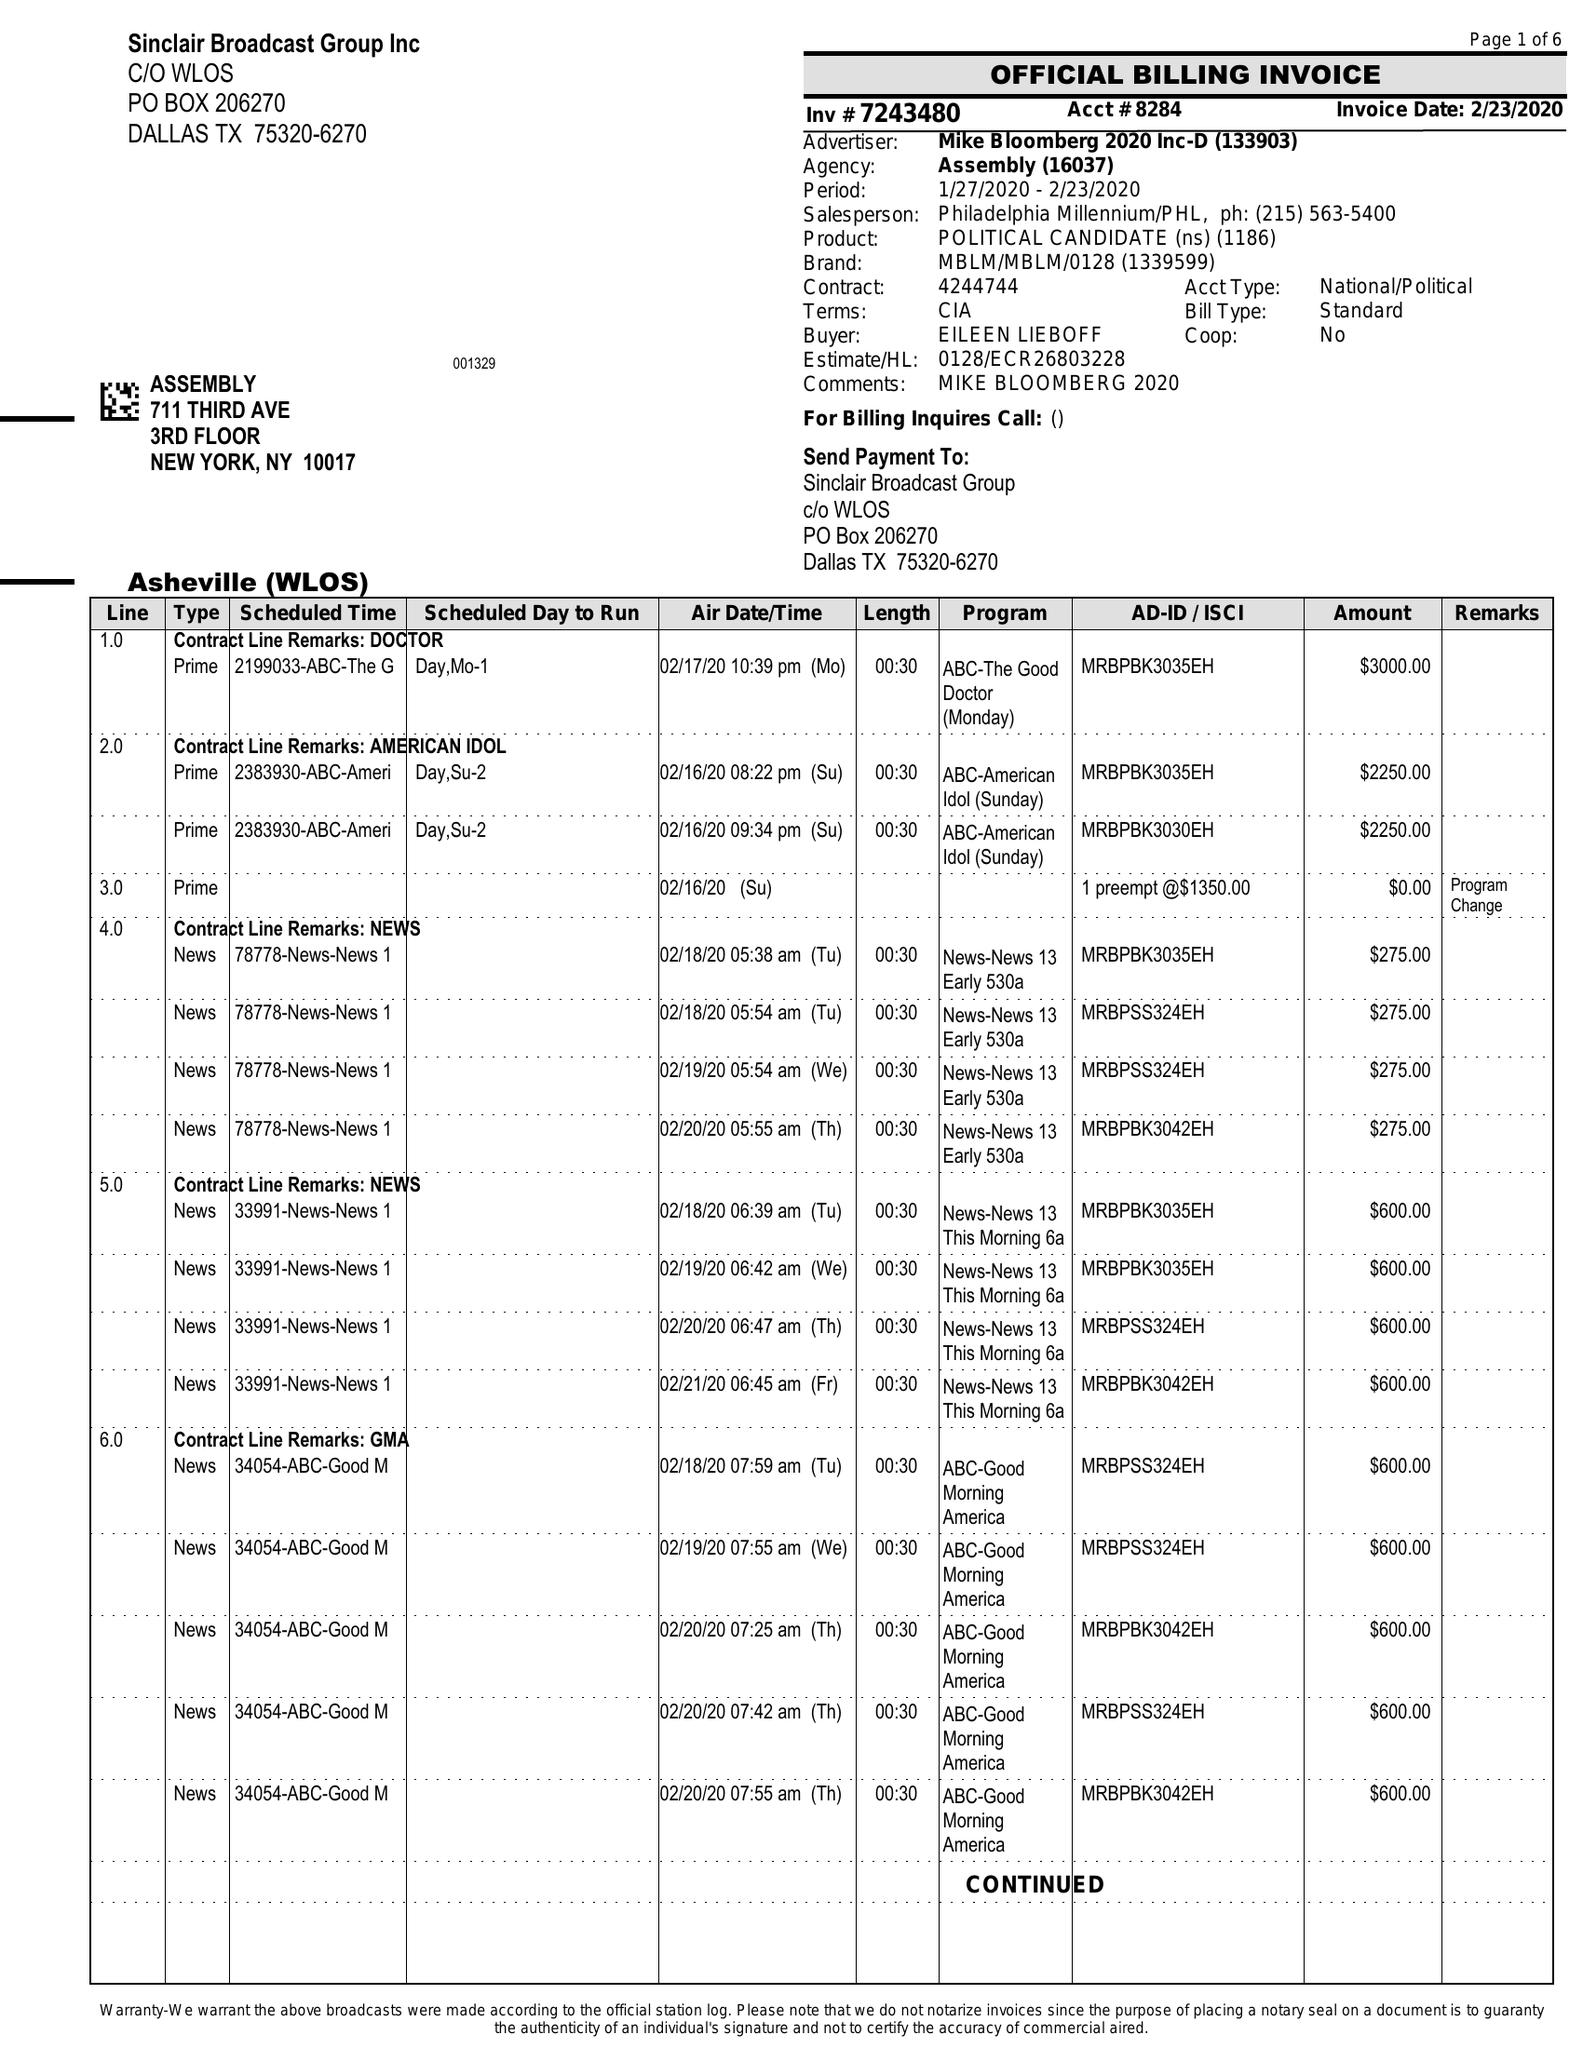What is the value for the advertiser?
Answer the question using a single word or phrase. MIKE BLOOMBERG 2020 INC-D 